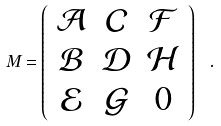<formula> <loc_0><loc_0><loc_500><loc_500>M = \left ( \begin{array} { c c c } \mathcal { A } & \mathcal { C } & \mathcal { F } \\ \mathcal { B } & \mathcal { D } & \mathcal { H } \\ \mathcal { E } & \mathcal { G } & 0 \end{array} \right ) \ .</formula> 